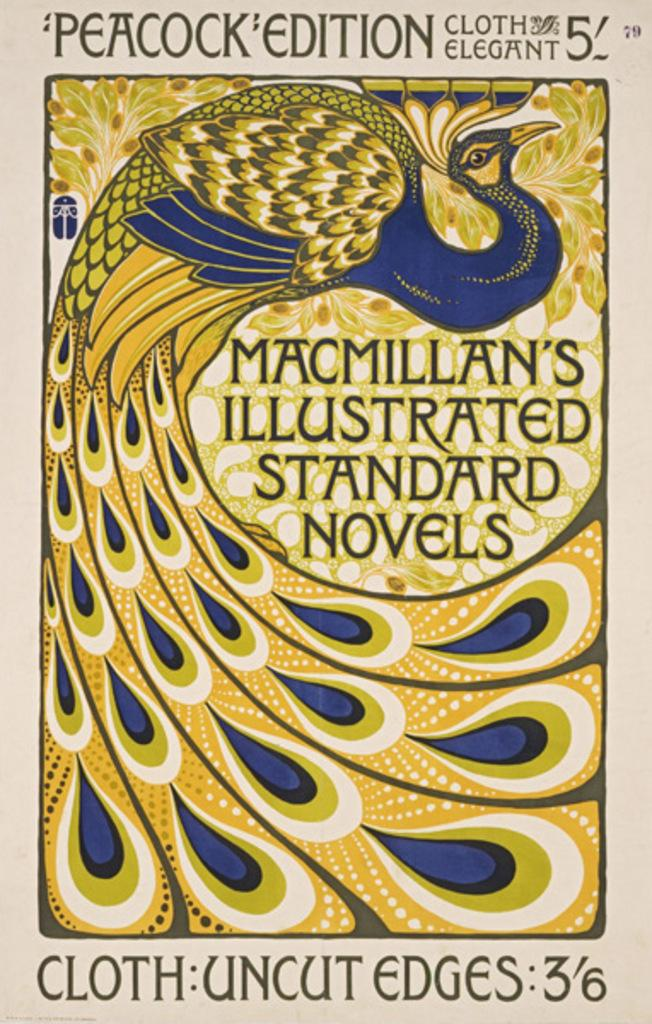Provide a one-sentence caption for the provided image. A book cover for Peacock edition cloth elegant 5 titled Macmillan's Illustrated Standard novels featuring a blue and gold peacock design. 